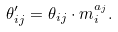<formula> <loc_0><loc_0><loc_500><loc_500>\theta ^ { \prime } _ { i j } = \theta _ { i j } \cdot m _ { i } ^ { a _ { j } } .</formula> 